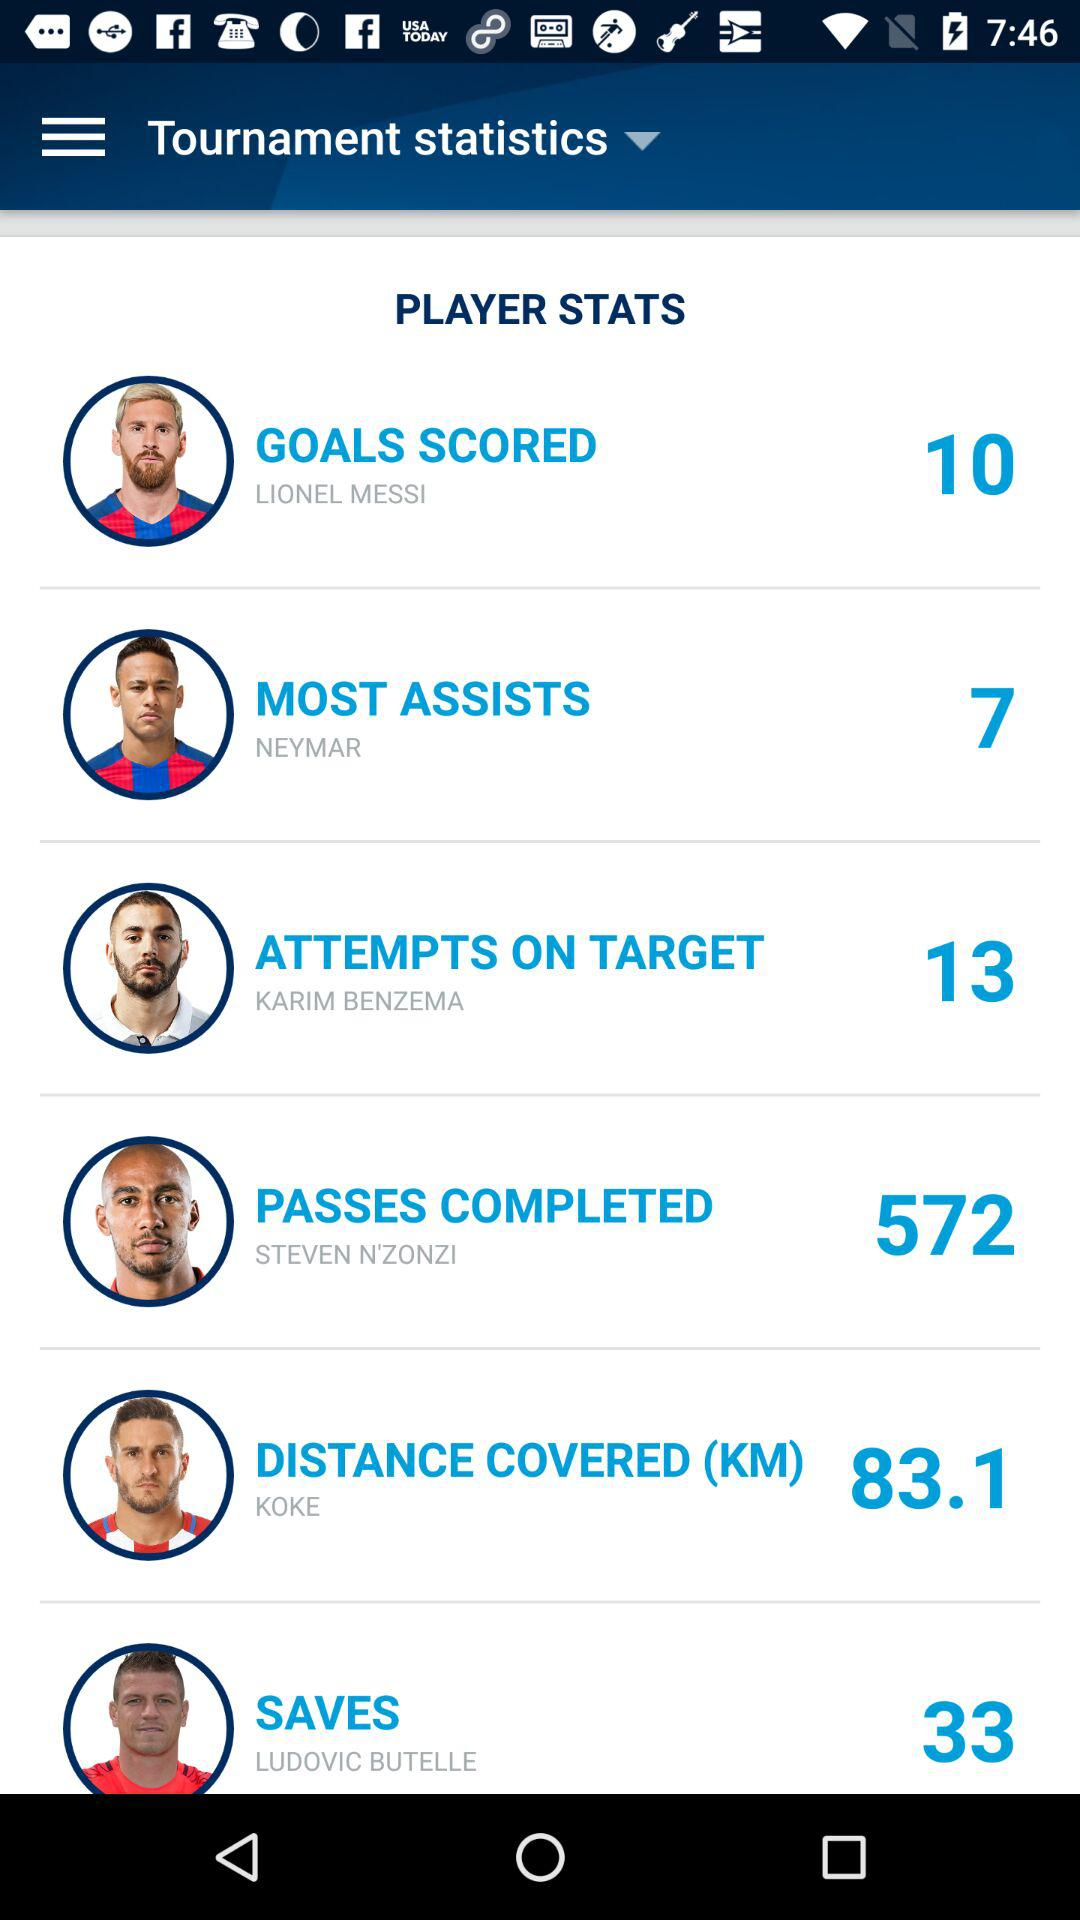Which player has the most assists? The player is Neymar. 